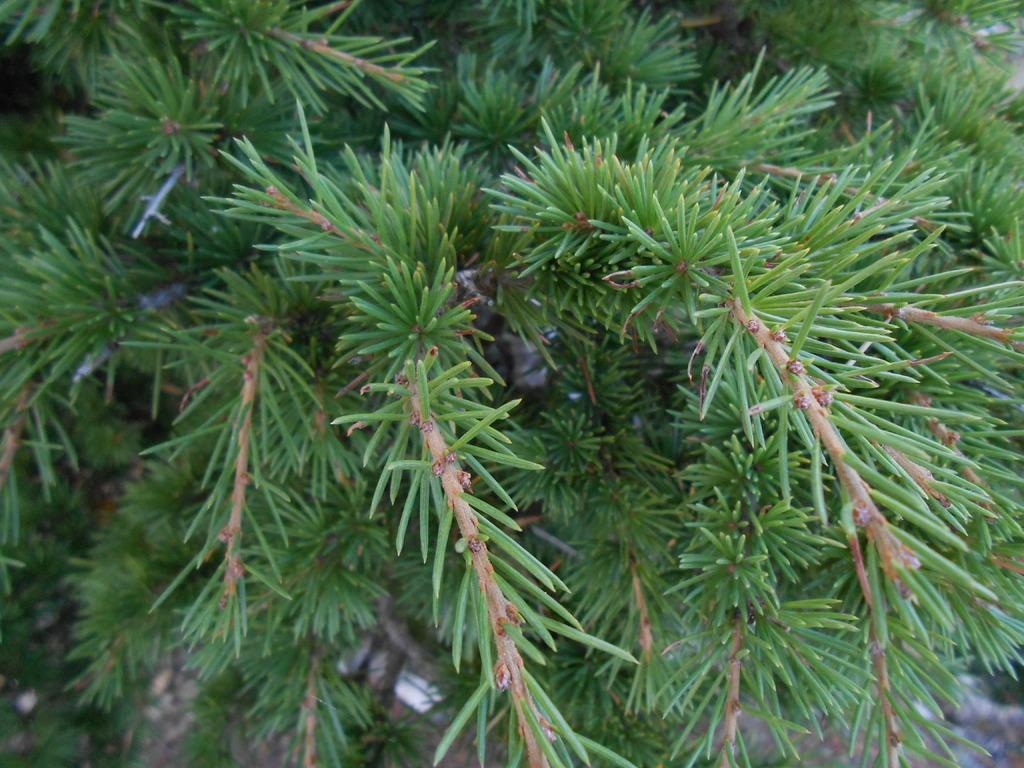What is depicted in the image? The image contains branches of a tree. What can be observed about the branches? The branches have leaves. What type of crime is being committed in the image? There is no crime present in the image; it features branches of a tree with leaves. Can you tell me where the faucet is located in the image? There is no faucet present in the image; it only contains branches of a tree with leaves. 